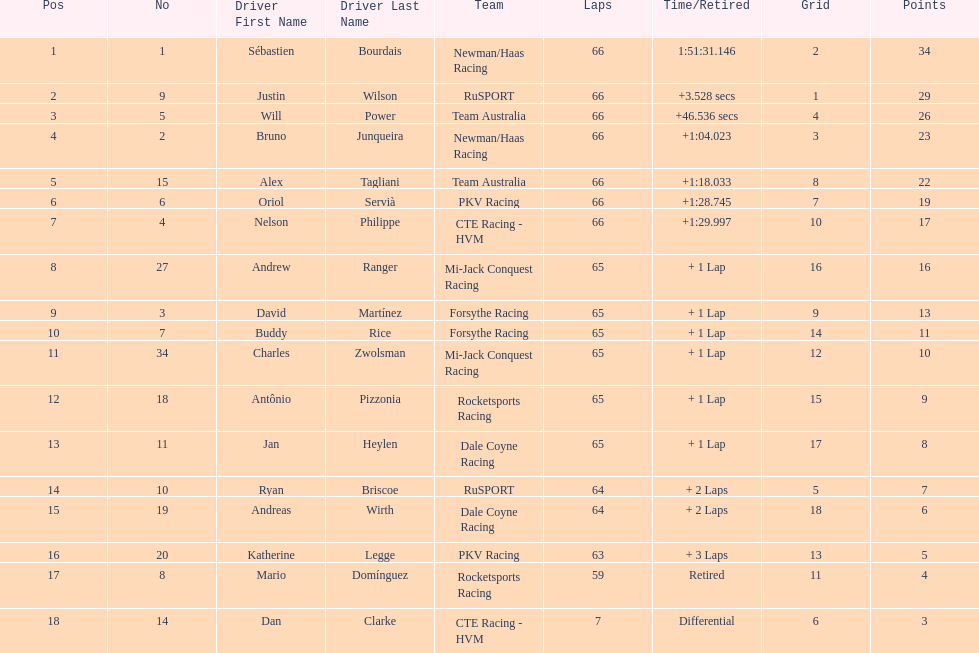Which country had more drivers representing them, the us or germany? Tie. 